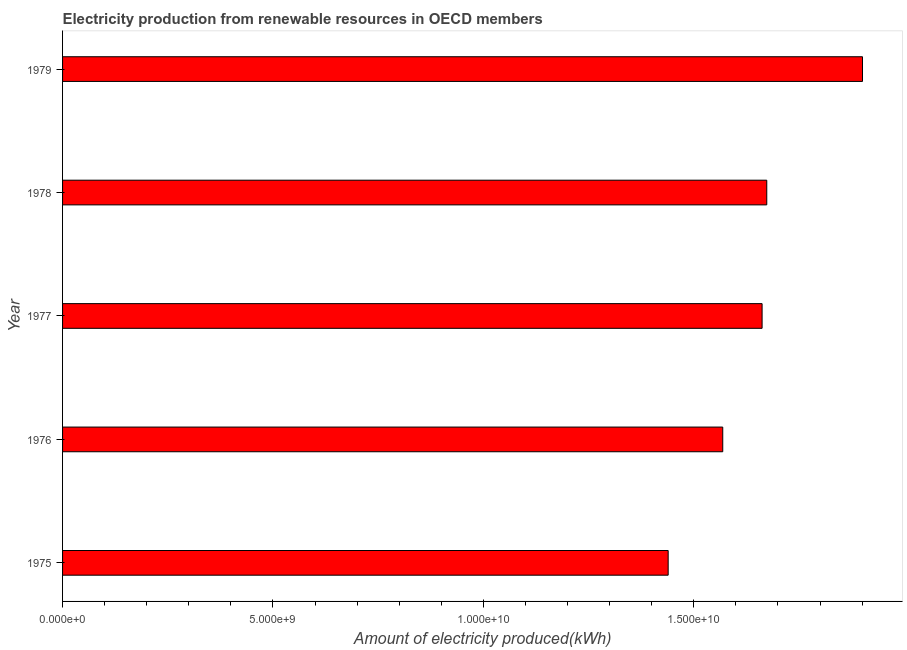Does the graph contain grids?
Provide a succinct answer. No. What is the title of the graph?
Keep it short and to the point. Electricity production from renewable resources in OECD members. What is the label or title of the X-axis?
Your answer should be very brief. Amount of electricity produced(kWh). What is the amount of electricity produced in 1978?
Give a very brief answer. 1.67e+1. Across all years, what is the maximum amount of electricity produced?
Keep it short and to the point. 1.90e+1. Across all years, what is the minimum amount of electricity produced?
Provide a short and direct response. 1.44e+1. In which year was the amount of electricity produced maximum?
Your answer should be very brief. 1979. In which year was the amount of electricity produced minimum?
Your answer should be compact. 1975. What is the sum of the amount of electricity produced?
Offer a very short reply. 8.24e+1. What is the difference between the amount of electricity produced in 1977 and 1979?
Give a very brief answer. -2.39e+09. What is the average amount of electricity produced per year?
Keep it short and to the point. 1.65e+1. What is the median amount of electricity produced?
Give a very brief answer. 1.66e+1. In how many years, is the amount of electricity produced greater than 17000000000 kWh?
Your answer should be compact. 1. What is the ratio of the amount of electricity produced in 1977 to that in 1979?
Offer a terse response. 0.87. Is the amount of electricity produced in 1978 less than that in 1979?
Make the answer very short. Yes. What is the difference between the highest and the second highest amount of electricity produced?
Give a very brief answer. 2.28e+09. Is the sum of the amount of electricity produced in 1975 and 1979 greater than the maximum amount of electricity produced across all years?
Give a very brief answer. Yes. What is the difference between the highest and the lowest amount of electricity produced?
Your answer should be very brief. 4.62e+09. In how many years, is the amount of electricity produced greater than the average amount of electricity produced taken over all years?
Provide a short and direct response. 3. How many bars are there?
Keep it short and to the point. 5. What is the difference between two consecutive major ticks on the X-axis?
Provide a succinct answer. 5.00e+09. Are the values on the major ticks of X-axis written in scientific E-notation?
Your response must be concise. Yes. What is the Amount of electricity produced(kWh) of 1975?
Give a very brief answer. 1.44e+1. What is the Amount of electricity produced(kWh) of 1976?
Offer a terse response. 1.57e+1. What is the Amount of electricity produced(kWh) in 1977?
Your response must be concise. 1.66e+1. What is the Amount of electricity produced(kWh) in 1978?
Offer a terse response. 1.67e+1. What is the Amount of electricity produced(kWh) in 1979?
Provide a short and direct response. 1.90e+1. What is the difference between the Amount of electricity produced(kWh) in 1975 and 1976?
Give a very brief answer. -1.30e+09. What is the difference between the Amount of electricity produced(kWh) in 1975 and 1977?
Your answer should be very brief. -2.23e+09. What is the difference between the Amount of electricity produced(kWh) in 1975 and 1978?
Make the answer very short. -2.34e+09. What is the difference between the Amount of electricity produced(kWh) in 1975 and 1979?
Offer a very short reply. -4.62e+09. What is the difference between the Amount of electricity produced(kWh) in 1976 and 1977?
Offer a terse response. -9.35e+08. What is the difference between the Amount of electricity produced(kWh) in 1976 and 1978?
Offer a very short reply. -1.05e+09. What is the difference between the Amount of electricity produced(kWh) in 1976 and 1979?
Offer a terse response. -3.32e+09. What is the difference between the Amount of electricity produced(kWh) in 1977 and 1978?
Your answer should be compact. -1.11e+08. What is the difference between the Amount of electricity produced(kWh) in 1977 and 1979?
Your response must be concise. -2.39e+09. What is the difference between the Amount of electricity produced(kWh) in 1978 and 1979?
Give a very brief answer. -2.28e+09. What is the ratio of the Amount of electricity produced(kWh) in 1975 to that in 1976?
Your response must be concise. 0.92. What is the ratio of the Amount of electricity produced(kWh) in 1975 to that in 1977?
Keep it short and to the point. 0.87. What is the ratio of the Amount of electricity produced(kWh) in 1975 to that in 1978?
Provide a succinct answer. 0.86. What is the ratio of the Amount of electricity produced(kWh) in 1975 to that in 1979?
Your answer should be very brief. 0.76. What is the ratio of the Amount of electricity produced(kWh) in 1976 to that in 1977?
Offer a very short reply. 0.94. What is the ratio of the Amount of electricity produced(kWh) in 1976 to that in 1978?
Provide a short and direct response. 0.94. What is the ratio of the Amount of electricity produced(kWh) in 1976 to that in 1979?
Your answer should be compact. 0.82. What is the ratio of the Amount of electricity produced(kWh) in 1977 to that in 1979?
Give a very brief answer. 0.87. 